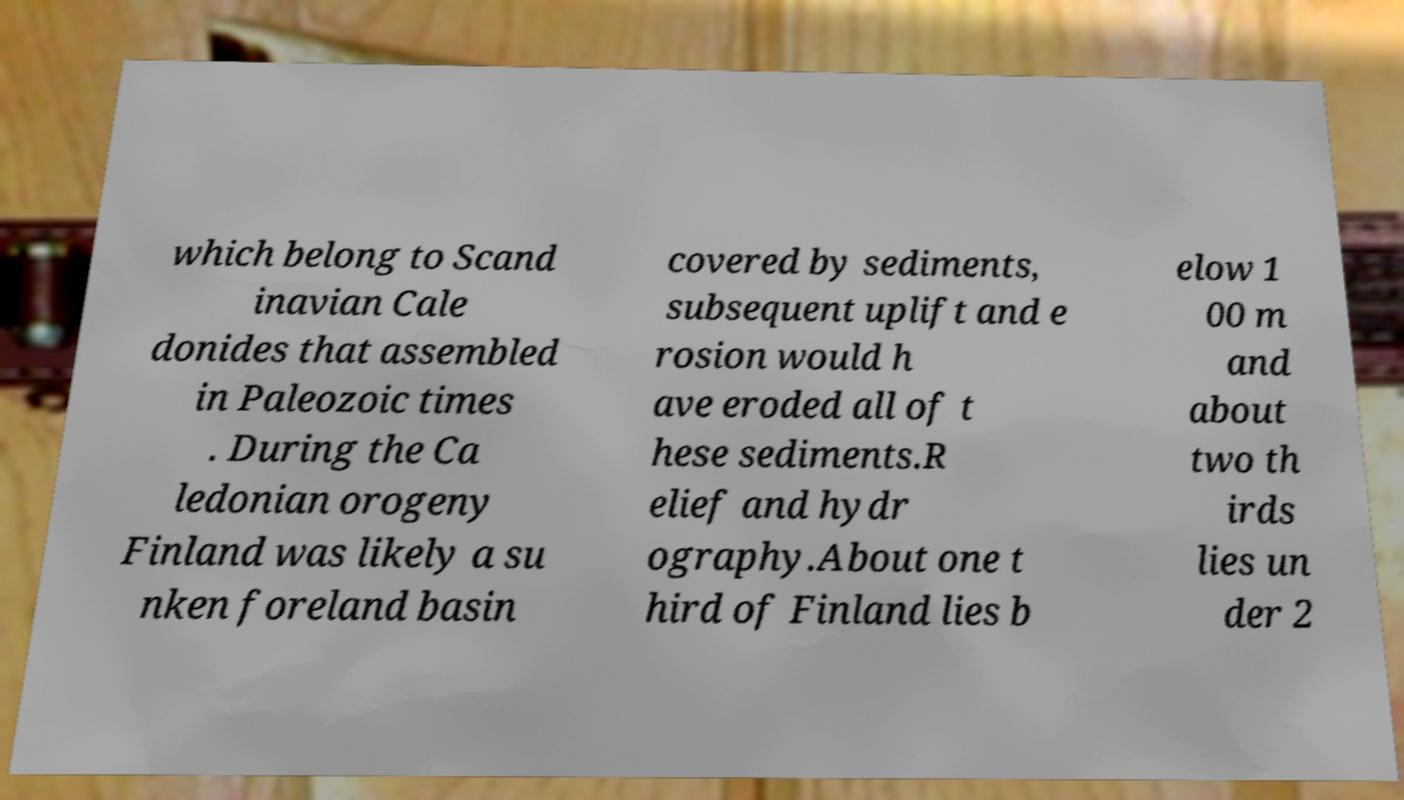There's text embedded in this image that I need extracted. Can you transcribe it verbatim? which belong to Scand inavian Cale donides that assembled in Paleozoic times . During the Ca ledonian orogeny Finland was likely a su nken foreland basin covered by sediments, subsequent uplift and e rosion would h ave eroded all of t hese sediments.R elief and hydr ography.About one t hird of Finland lies b elow 1 00 m and about two th irds lies un der 2 